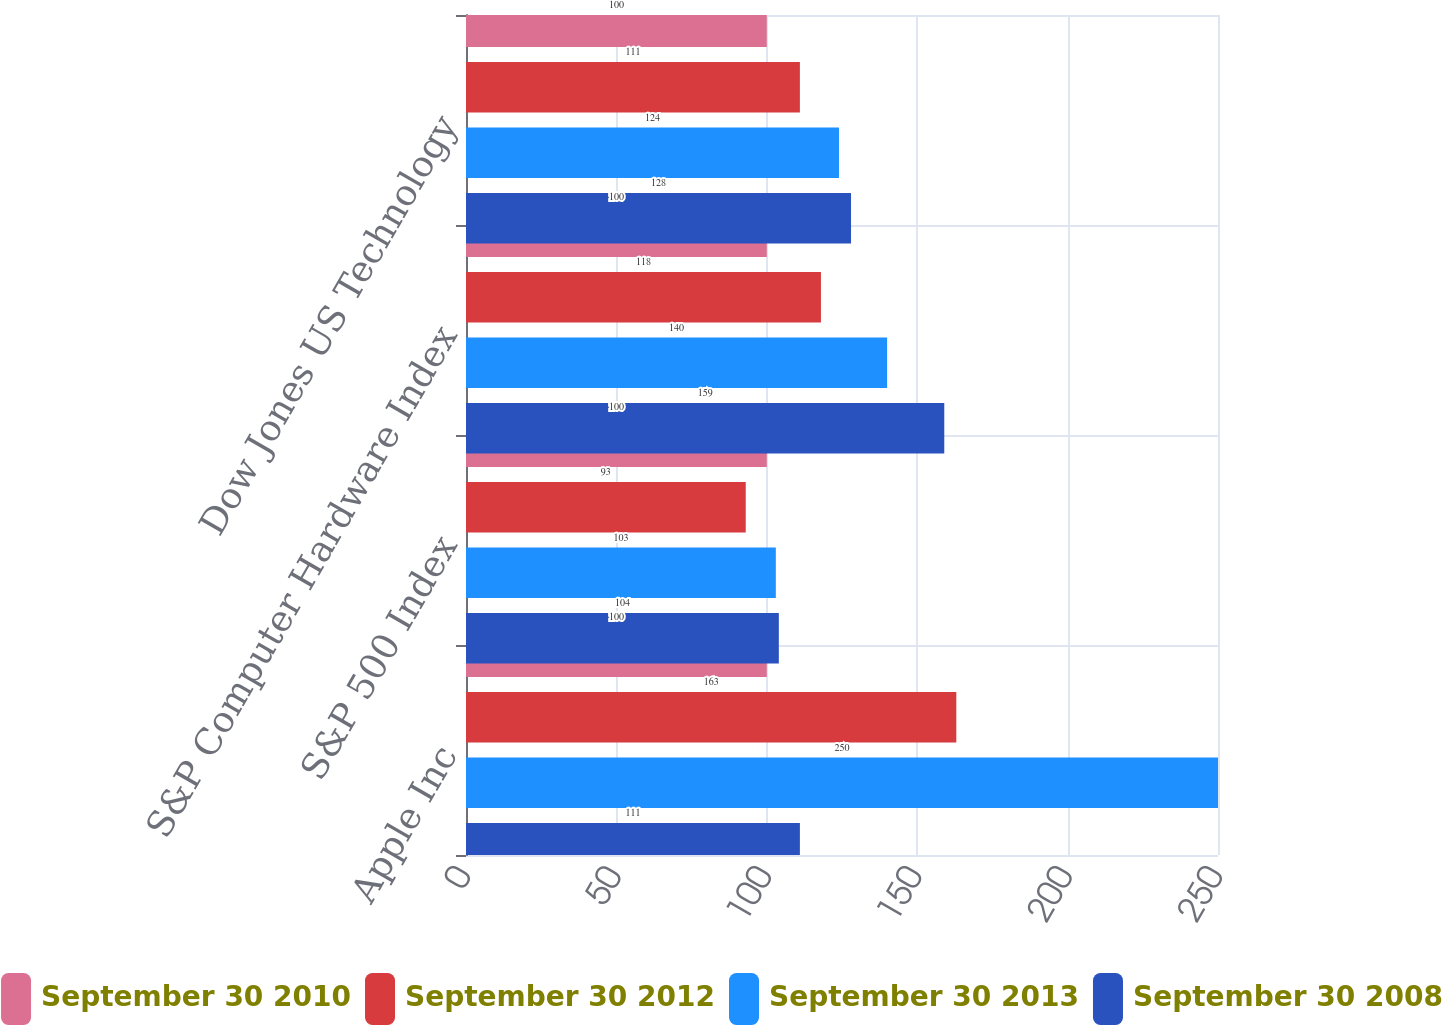<chart> <loc_0><loc_0><loc_500><loc_500><stacked_bar_chart><ecel><fcel>Apple Inc<fcel>S&P 500 Index<fcel>S&P Computer Hardware Index<fcel>Dow Jones US Technology<nl><fcel>September 30 2010<fcel>100<fcel>100<fcel>100<fcel>100<nl><fcel>September 30 2012<fcel>163<fcel>93<fcel>118<fcel>111<nl><fcel>September 30 2013<fcel>250<fcel>103<fcel>140<fcel>124<nl><fcel>September 30 2008<fcel>111<fcel>104<fcel>159<fcel>128<nl></chart> 